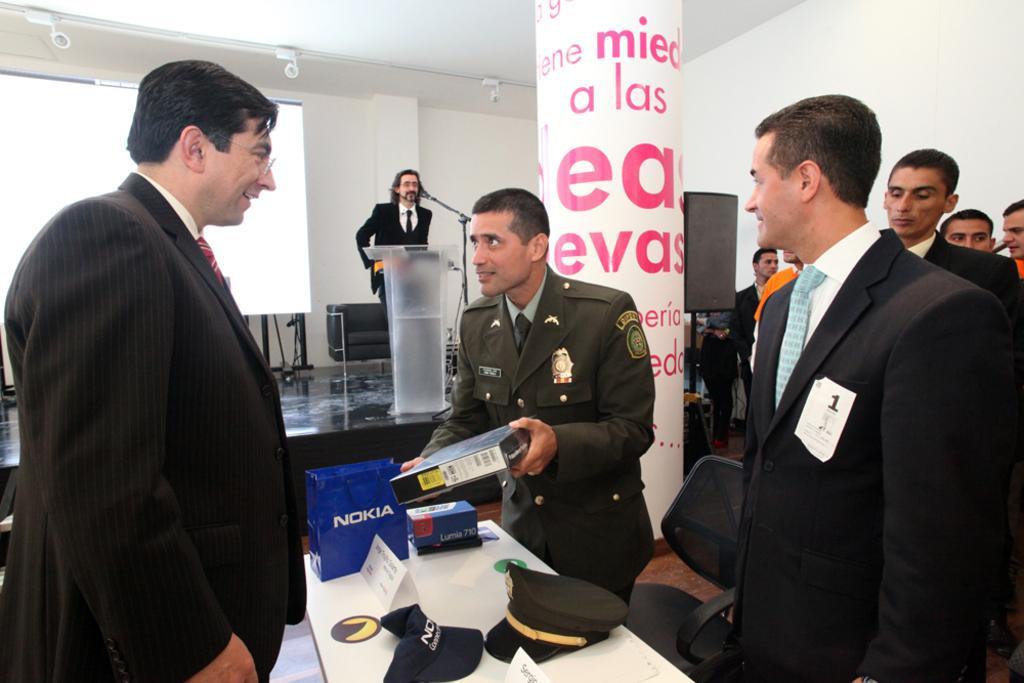Could you give a brief overview of what you see in this image? In this image there are group of people standing , a person holding a box, there are hats, nameplates, paper bag on the table, a person standing near the podium, mic with a mike stand, screen , lights, speaker, chairs. 